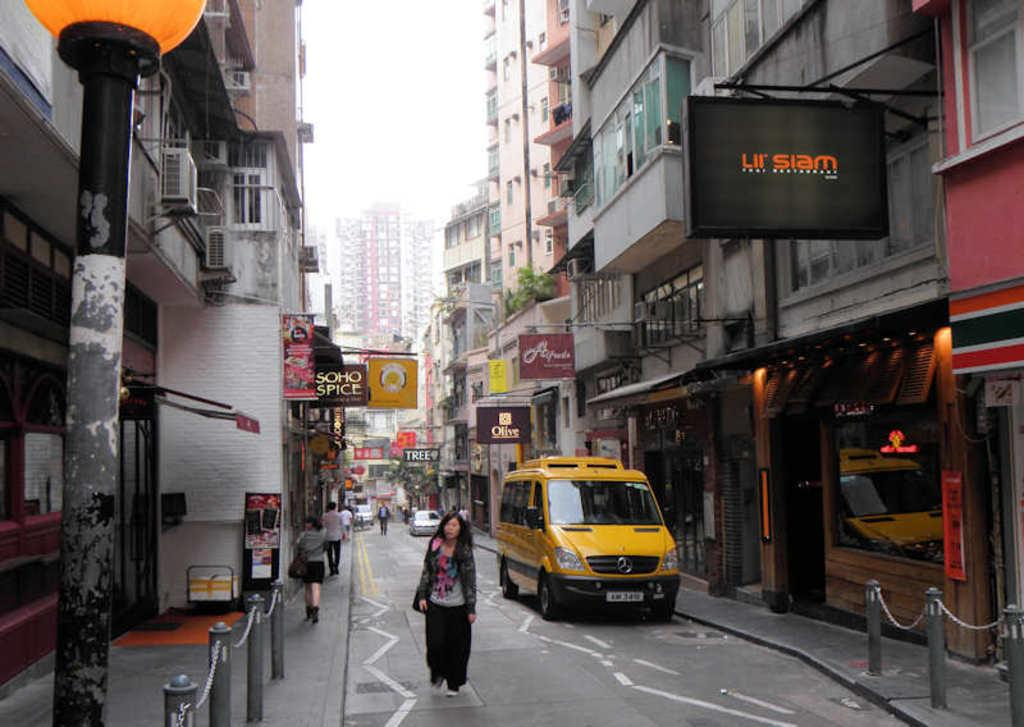<image>
Share a concise interpretation of the image provided. The black sign with orange writing on the right, says Ur Siam. 